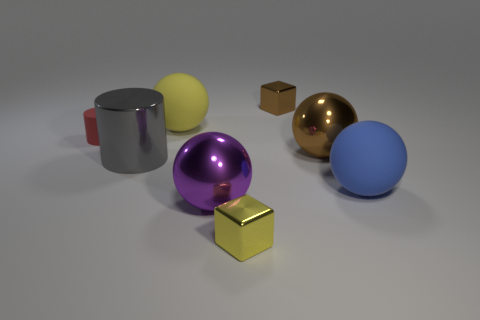What number of cylinders are either large objects or big purple things?
Give a very brief answer. 1. What is the shape of the shiny thing that is left of the small yellow block and behind the blue matte thing?
Keep it short and to the point. Cylinder. Are there the same number of large purple metal spheres that are behind the big purple metallic sphere and big metallic things that are in front of the tiny brown metallic object?
Provide a short and direct response. No. How many objects are either metallic balls or metal cylinders?
Provide a short and direct response. 3. What is the color of the rubber object that is the same size as the brown cube?
Offer a very short reply. Red. What number of objects are either small metallic things that are in front of the purple sphere or large objects that are behind the large blue object?
Keep it short and to the point. 4. Are there an equal number of gray metallic things that are right of the yellow ball and cyan metallic objects?
Provide a short and direct response. Yes. There is a yellow thing that is in front of the matte cylinder; does it have the same size as the brown metallic thing behind the brown metallic sphere?
Ensure brevity in your answer.  Yes. How many other objects are there of the same size as the gray object?
Your answer should be very brief. 4. Are there any big gray shiny things to the left of the large rubber object to the right of the matte sphere that is left of the blue sphere?
Offer a terse response. Yes. 